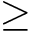Convert formula to latex. <formula><loc_0><loc_0><loc_500><loc_500>\geq</formula> 